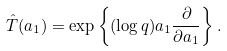Convert formula to latex. <formula><loc_0><loc_0><loc_500><loc_500>\hat { T } ( a _ { 1 } ) = \exp { \left \{ ( \log q ) a _ { 1 } \frac { \partial } { \partial a _ { 1 } } \right \} } \, .</formula> 